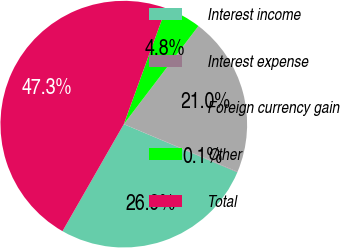Convert chart. <chart><loc_0><loc_0><loc_500><loc_500><pie_chart><fcel>Interest income<fcel>Interest expense<fcel>Foreign currency gain<fcel>Other<fcel>Total<nl><fcel>26.9%<fcel>0.07%<fcel>20.96%<fcel>4.79%<fcel>47.28%<nl></chart> 